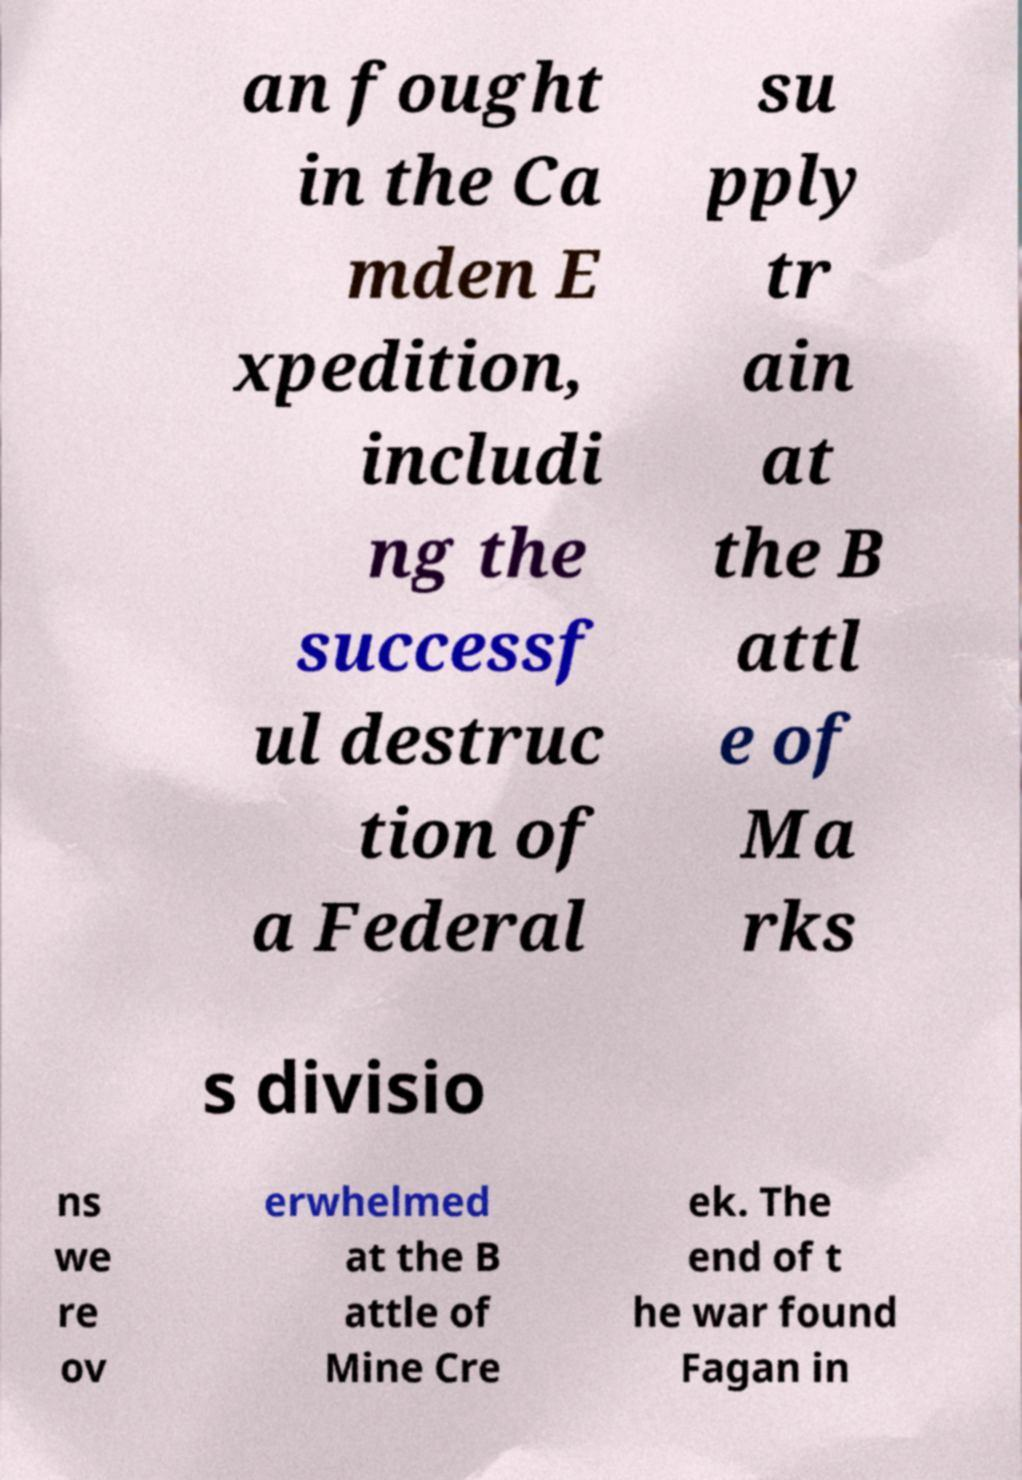Could you assist in decoding the text presented in this image and type it out clearly? an fought in the Ca mden E xpedition, includi ng the successf ul destruc tion of a Federal su pply tr ain at the B attl e of Ma rks s divisio ns we re ov erwhelmed at the B attle of Mine Cre ek. The end of t he war found Fagan in 